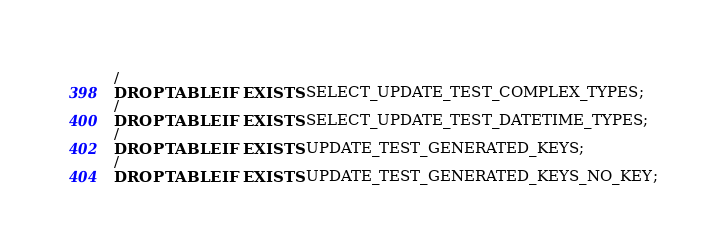Convert code to text. <code><loc_0><loc_0><loc_500><loc_500><_SQL_>/
DROP TABLE IF EXISTS SELECT_UPDATE_TEST_COMPLEX_TYPES;
/
DROP TABLE IF EXISTS SELECT_UPDATE_TEST_DATETIME_TYPES;
/
DROP TABLE IF EXISTS UPDATE_TEST_GENERATED_KEYS;
/
DROP TABLE IF EXISTS UPDATE_TEST_GENERATED_KEYS_NO_KEY;</code> 